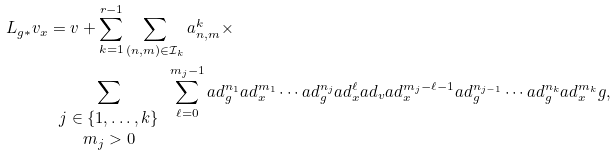Convert formula to latex. <formula><loc_0><loc_0><loc_500><loc_500>L _ { g * } v _ { x } & = v + \sum _ { k = 1 } ^ { r - 1 } \sum _ { ( n , m ) \in \mathcal { I } _ { k } } a _ { n , m } ^ { k } \times \\ & \sum _ { \begin{array} { c c } j \in \{ 1 , \dots , k \} \\ m _ { j } > 0 \end{array} } \sum _ { \ell = 0 } ^ { m _ { j } - 1 } a d _ { g } ^ { n _ { 1 } } a d _ { x } ^ { m _ { 1 } } \cdots a d _ { g } ^ { n _ { j } } a d _ { x } ^ { \ell } a d _ { v } a d _ { x } ^ { m _ { j } - \ell - 1 } a d _ { g } ^ { n _ { j - 1 } } \cdots a d _ { g } ^ { n _ { k } } a d _ { x } ^ { m _ { k } } g ,</formula> 